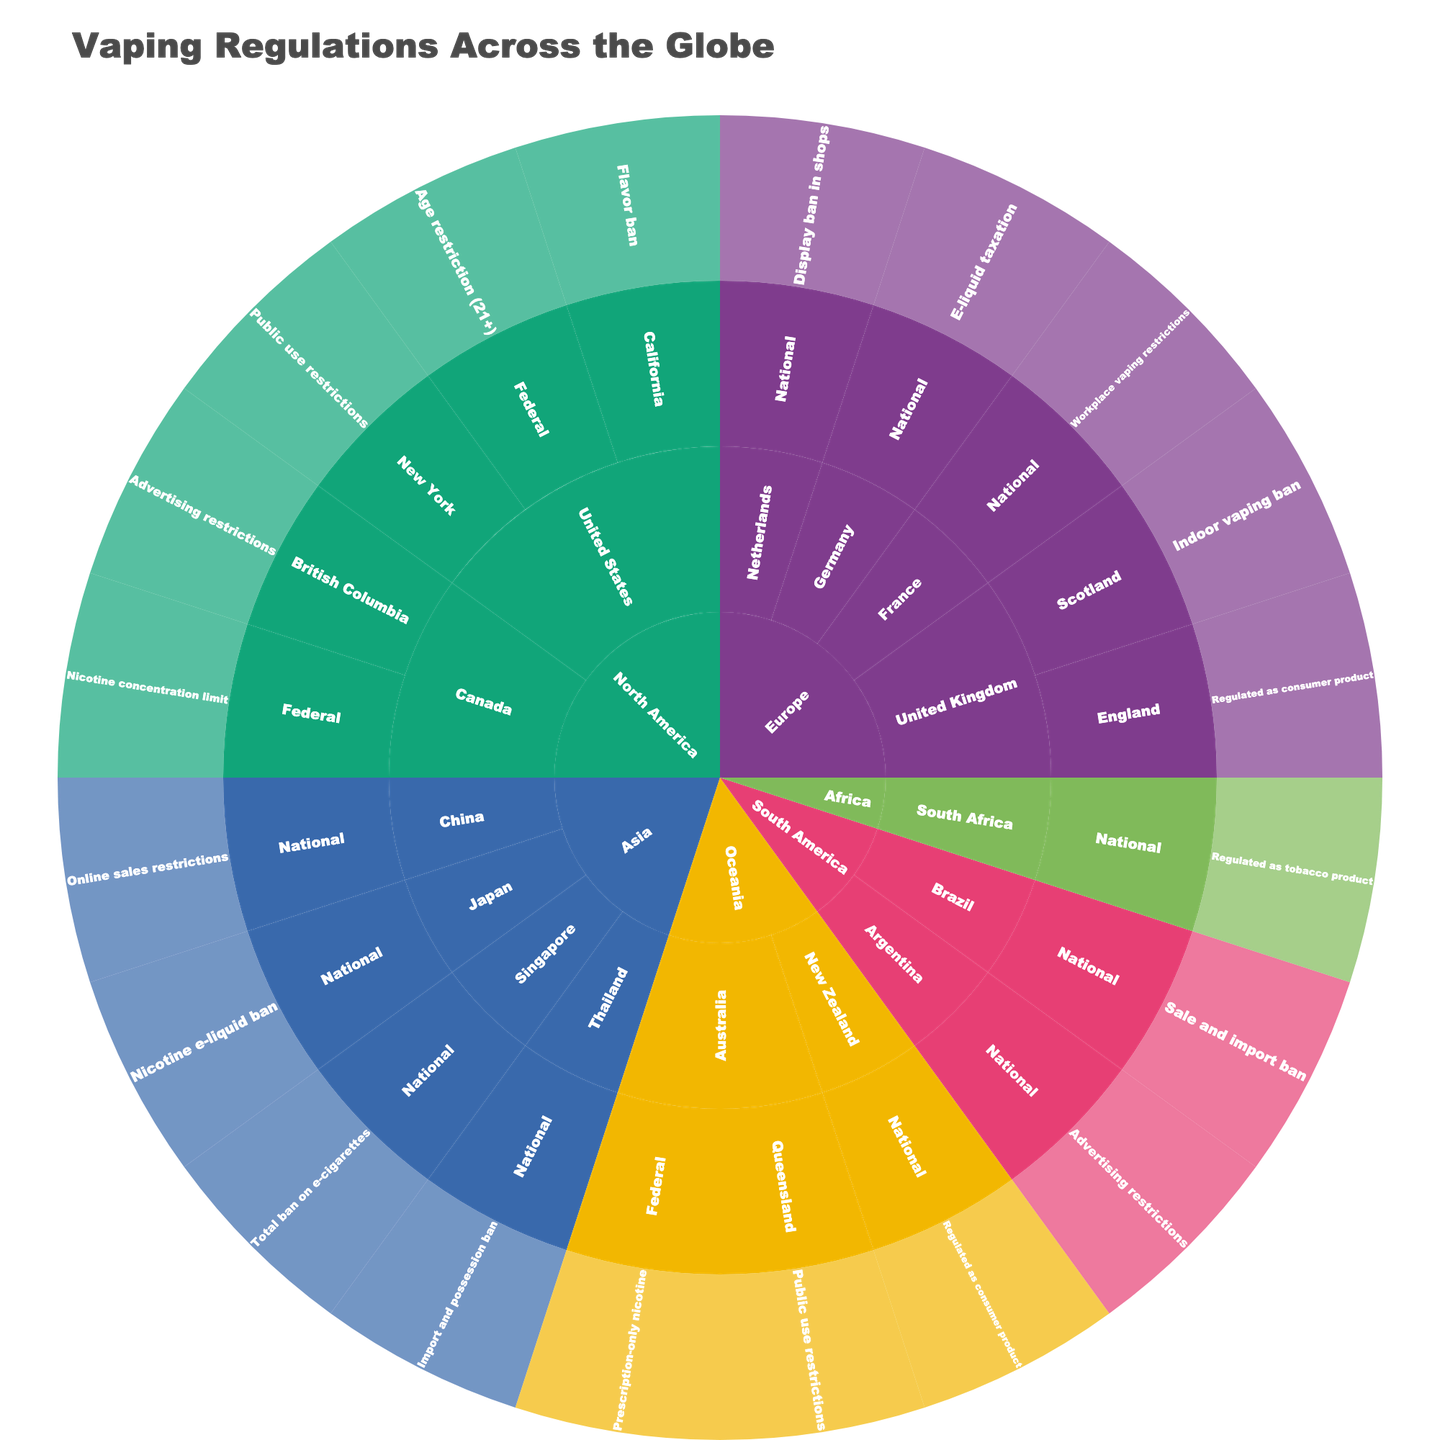What's the main title of the figure? The main title of the figure is usually positioned at the top of the plot and is a descriptive summary of the visualized data. For this Sunburst plot, the title is "Vaping Regulations Across the Globe".
Answer: Vaping Regulations Across the Globe Which regions are represented in the outermost ring? In a Sunburst Plot, the outermost ring represents the finest level of categorization. By looking at the outermost ring, we can identify the regions represented, which are North America, Europe, Asia, Oceania, South America, and Africa.
Answer: North America, Europe, Asia, Oceania, South America, Africa How many jurisdictions in the United States have specific regulations mentioned? To answer this, locate the United States section in the Sunburst plot. Under the United States, identify and count all individual jurisdictions listed within. These include Federal, California, and New York, making it a total of 3 jurisdictions.
Answer: 3 Which country in Europe has the highest diversity in regulations? Look at the countries within the Europe section in the Sunburst plot and count the number of unique jurisdictions and regulations for each country. The United Kingdom has both England and Scotland with their individual regulations, making it the most diverse in terms of regulations.
Answer: United Kingdom What type of regulation is common across multiple regions in the plot? To determine the commonality of regulation types, examine the regulations listed for each region and count how often each type appears. Regulations such as "Public use restrictions" and "Advertising restrictions" appear in multiple regions like North America, Europe, and Oceania.
Answer: Public use restrictions and Advertising restrictions What is the difference between the regulations in Japan and Singapore? Find Japan and Singapore in the Asia section of the Sunburst plot and compare their regulations. Japan has a "Nicotine e-liquid ban" whereas Singapore has a "Total ban on e-cigarettes".
Answer: Japan: Nicotine e-liquid ban; Singapore: Total ban on e-cigarettes Which countries have a regulation that involves banning in some form? Look through the regulations listed under each country in the plot and identify those involving bans. Countries such as Singapore, Thailand, Brazil, and Japan have regulations involving bans, whether total, import, or specific substances.
Answer: Singapore, Thailand, Brazil, Japan How does the regulation in Queensland differ from the federal regulation in Australia? Locate Australia within the Oceania section and identify the regulations for the whole country (Federal) and for Queensland. The federal regulation is "Prescription-only nicotine" while Queensland's regulation is "Public use restrictions".
Answer: Federal: Prescription-only nicotine; Queensland: Public use restrictions Which regions do not have any countries listed with indoor vaping bans? To find this, examine each region for regulations related to indoor vaping. Only Europe (Scotland) directly lists an "Indoor vaping ban". Therefore, regions like North America, Asia, Oceania, South America, and Africa do not list any indoor vaping bans.
Answer: North America, Asia, Oceania, South America, Africa What are the unique regulations observed in South America and Africa? Identify regulations listed under South America and Africa regions in the plot. For South America, Brazil has "Sale and import ban" and Argentina has "Advertising restrictions". For Africa, South Africa has "Regulated as tobacco product". These are unique to these regions based on the plot shown.
Answer: South America: Sale and import ban, Advertising restrictions; Africa: Regulated as tobacco product 